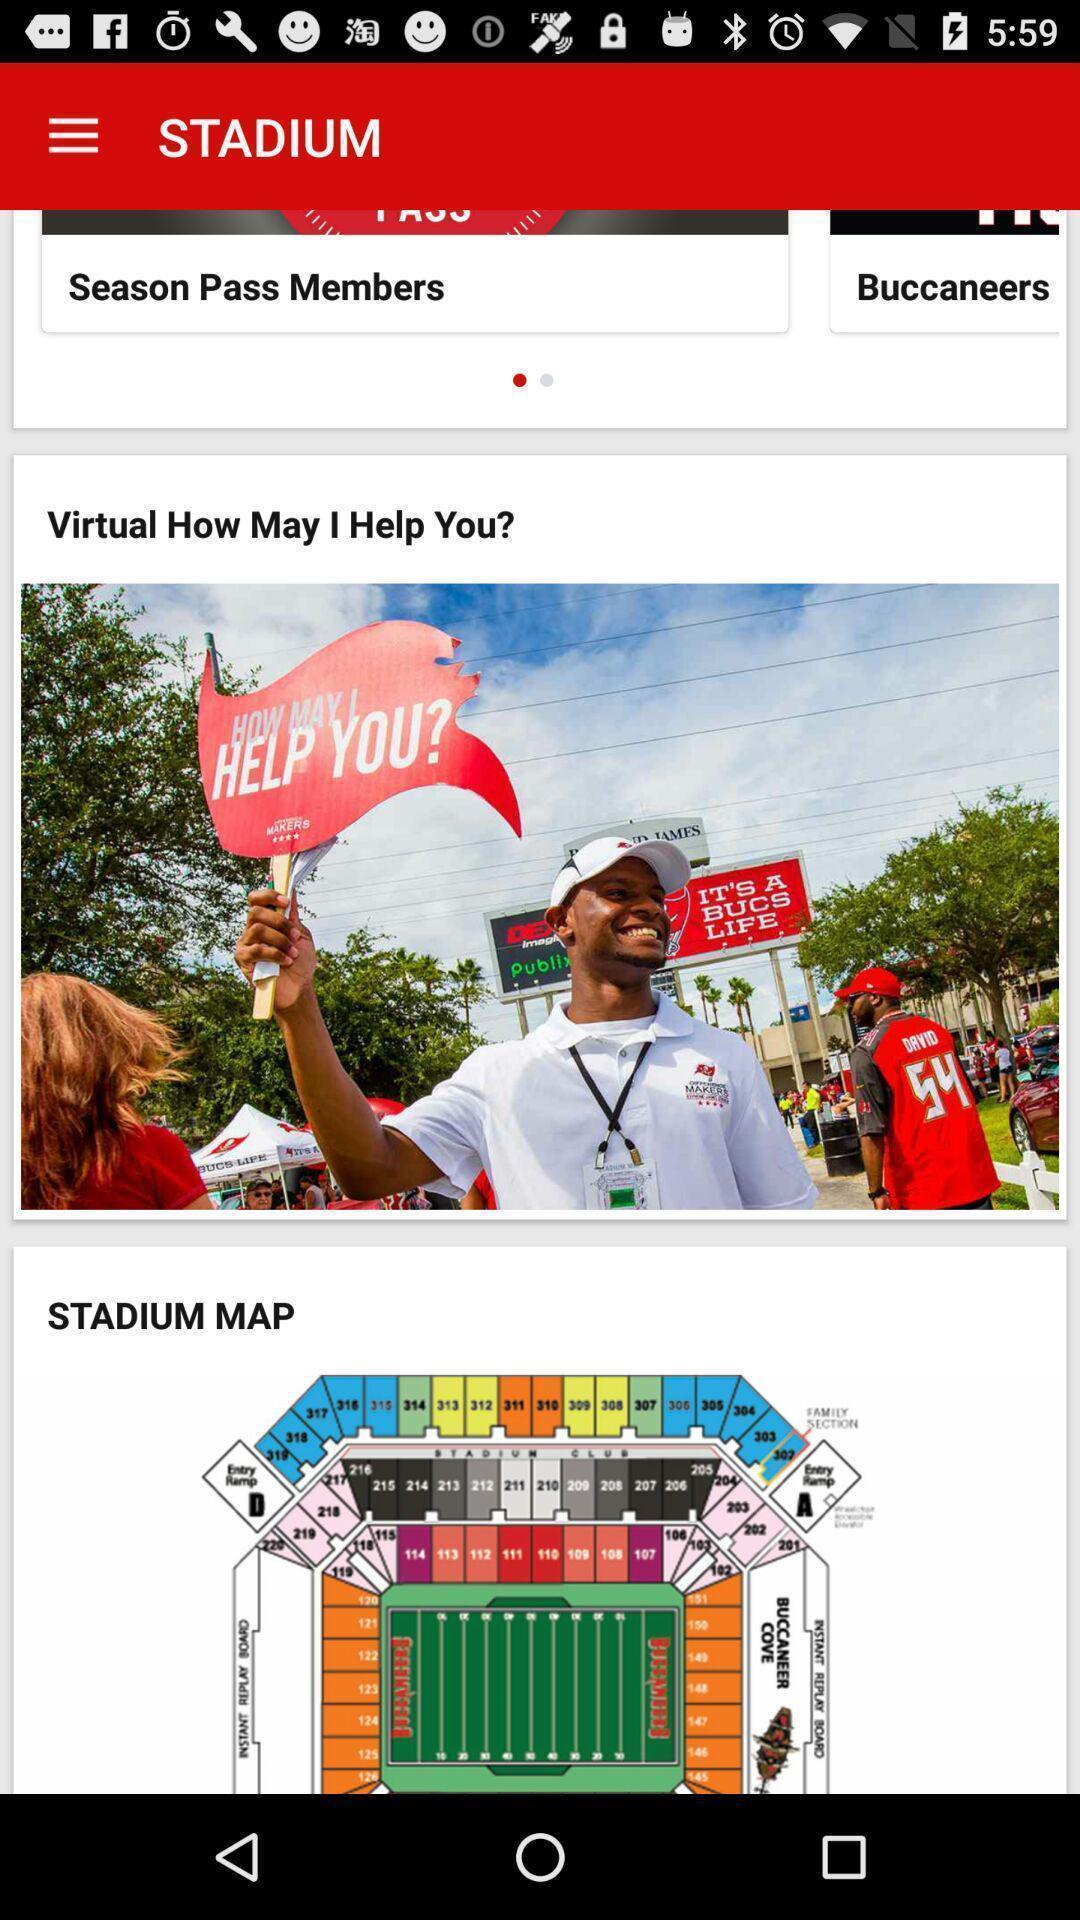Explain what's happening in this screen capture. Page showing stadium map. 